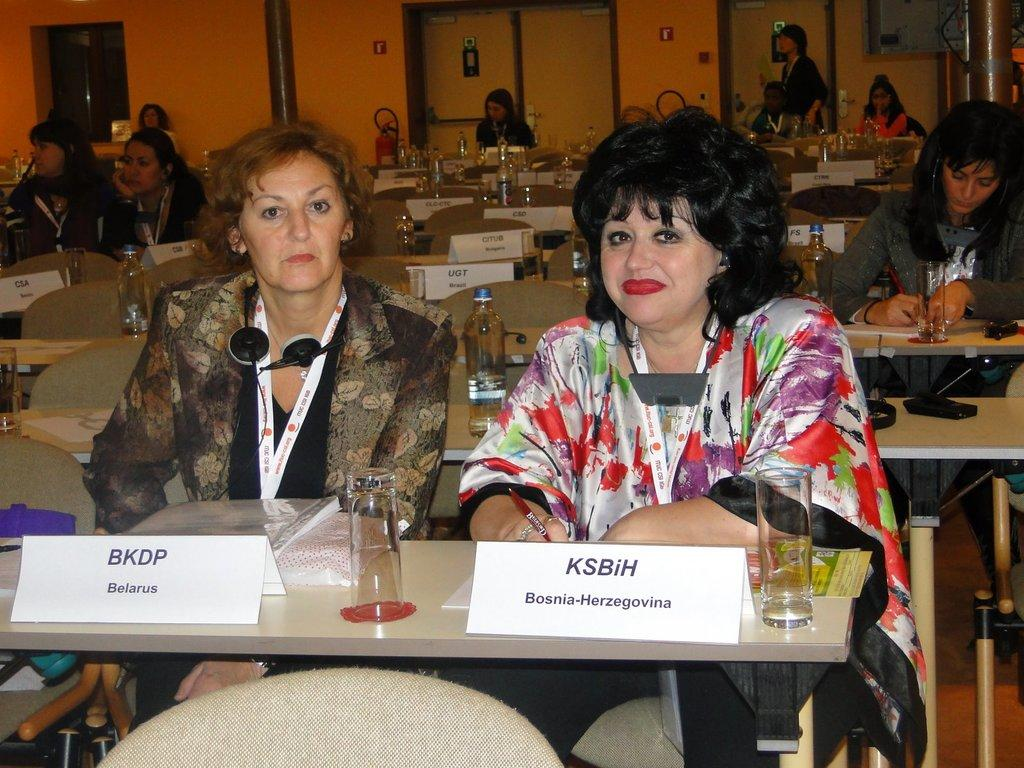What is happening in the image involving a group of people? There is a group of people in the image, and they are seated on chairs. What objects are present on the table in the image? There are glasses on a table in the image. Can you describe the man in the background of the image? There is a man standing in the background of the image. What type of disgust can be seen on the faces of the people in the image? There is no indication of disgust on the faces of the people in the image. Are there any balloons present in the image? There are no balloons present in the image. 